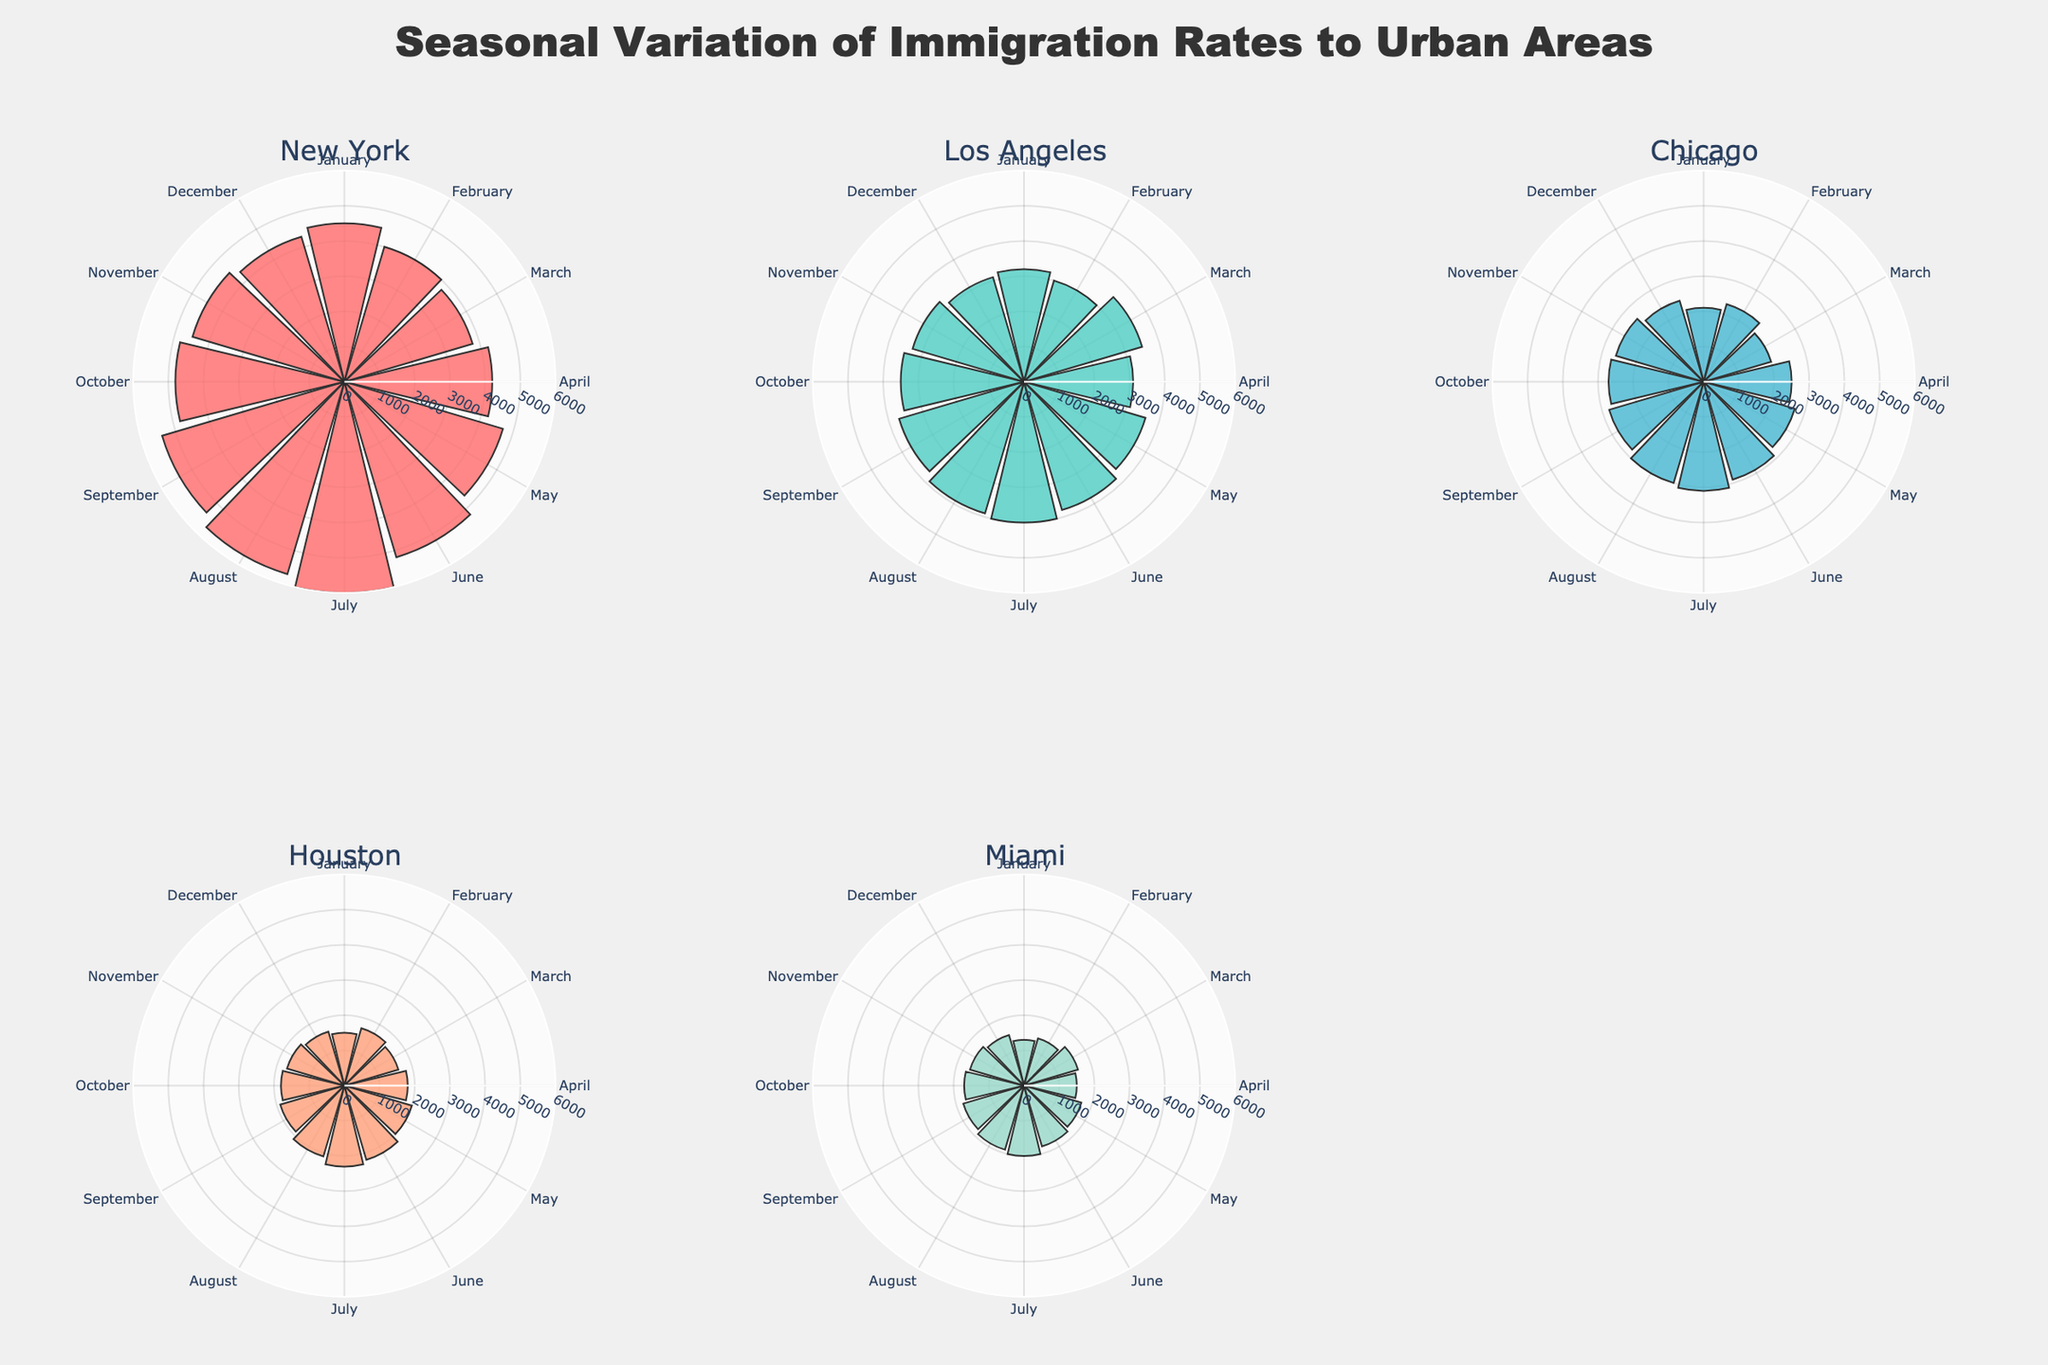How many cities are plotted in the figure? The figure contains subplots for different cities. By inspecting the subplot titles, we can count the individual cities represented.
Answer: 5 What is the title of the figure? The title of the figure is displayed prominently at the top. It reads "Seasonal Variation of Immigration Rates to Urban Areas."
Answer: Seasonal Variation of Immigration Rates to Urban Areas Which city has the highest number of immigrants in July? By examining the subplot for each city and looking for the highest radial bar in the month of July, it is evident which city has the highest value.
Answer: New York What is the sum of immigrants to Chicago in June and July? To find this, locate the radial bars for Chicago in June and July and add their values. They are 2900 for June and 3100 for July. 2900 + 3100 = 6000.
Answer: 6000 Which month shows the highest immigration rate for Miami? Look at the radial bars for Miami across each month and identify the month corresponding to the highest bar value.
Answer: July In what month did New York have the lowest immigration rate? Find the lowest radial bar length for the New York subplot and note the corresponding month.
Answer: March Compare the immigration rates of Houston in May and November. Which month had a higher rate? Look at the radial bars for Houston for May and November, and compare their lengths to determine which month had the higher rate.
Answer: May How does the seasonal variation of immigration rates in Los Angeles compare to that in Miami? By comparing the shapes and patterns of the bars in the Los Angeles and Miami subplots, we can make observations about how immigration rates fluctuate in each city throughout the year. Miami's immigration rate is more stable with smaller variations, whereas Los Angeles shows more pronounced peaks and troughs.
Answer: Los Angeles fluctuates more What was the average number of immigrants to New York in the first quarter of the year (January, February, and March)? Add the values for January, February, and March for New York (4500, 4000, and 3800 respectively) and divide by 3. (4500 + 4000 + 3800) / 3 = 4100.
Answer: 4100 Which city had the lowest immigration rate in any single month, and what was that rate? Look for the smallest radial bar in all subplots across all months. This is Miami in January with 1300 immigrants.
Answer: Miami, 1300 